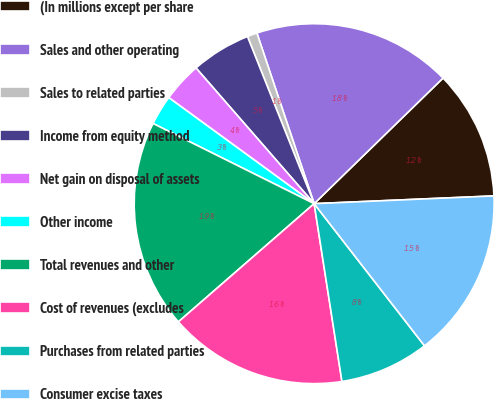<chart> <loc_0><loc_0><loc_500><loc_500><pie_chart><fcel>(In millions except per share<fcel>Sales and other operating<fcel>Sales to related parties<fcel>Income from equity method<fcel>Net gain on disposal of assets<fcel>Other income<fcel>Total revenues and other<fcel>Cost of revenues (excludes<fcel>Purchases from related parties<fcel>Consumer excise taxes<nl><fcel>11.61%<fcel>17.86%<fcel>0.89%<fcel>5.36%<fcel>3.57%<fcel>2.68%<fcel>18.75%<fcel>16.07%<fcel>8.04%<fcel>15.18%<nl></chart> 